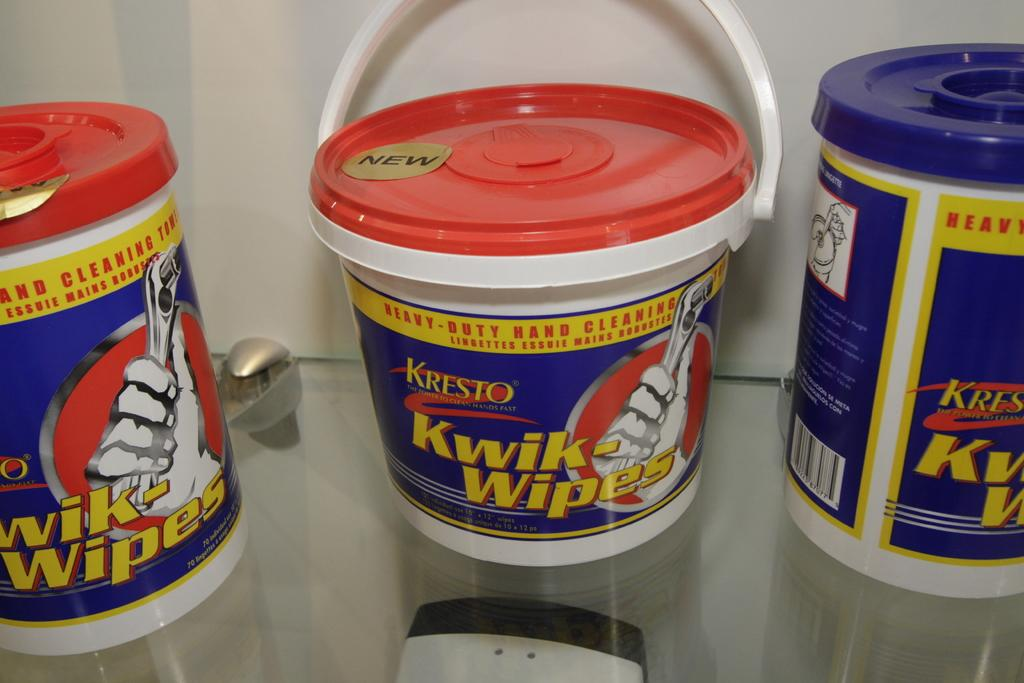<image>
Present a compact description of the photo's key features. Containers of Kwik-wipes show a person holding a wrench on them. 